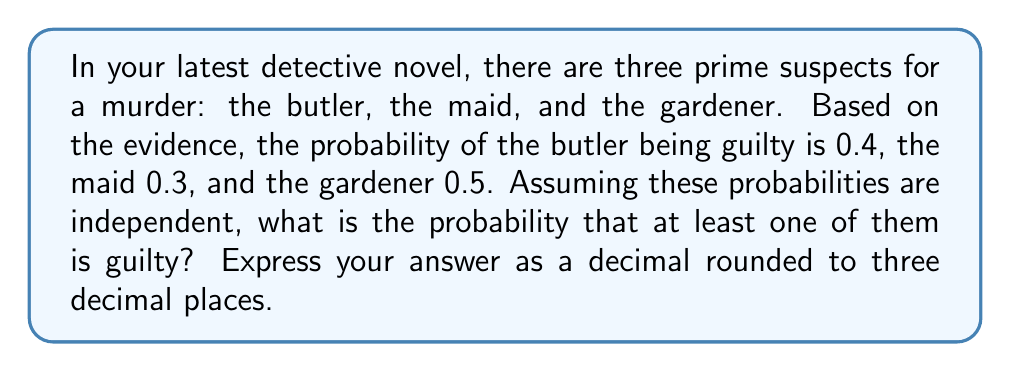Give your solution to this math problem. Let's approach this step-by-step using set theory and probability:

1) Let's define our events:
   B: Butler is guilty
   M: Maid is guilty
   G: Gardener is guilty

2) We're looking for P(B ∪ M ∪ G), the probability that at least one of them is guilty.

3) It's often easier to calculate the complement of this probability, which is the probability that none of them are guilty:

   P(at least one guilty) = 1 - P(none guilty)

4) Since the events are independent, we can multiply the probabilities of each suspect being innocent:

   P(none guilty) = P(B' ∩ M' ∩ G')
                  = P(B') × P(M') × P(G')

5) We can calculate the probability of each suspect being innocent:
   P(B') = 1 - P(B) = 1 - 0.4 = 0.6
   P(M') = 1 - P(M) = 1 - 0.3 = 0.7
   P(G') = 1 - P(G) = 1 - 0.5 = 0.5

6) Now we can calculate:
   P(none guilty) = 0.6 × 0.7 × 0.5 = 0.21

7) Therefore:
   P(at least one guilty) = 1 - P(none guilty)
                          = 1 - 0.21
                          = 0.79

8) Rounding to three decimal places: 0.790
Answer: 0.790 